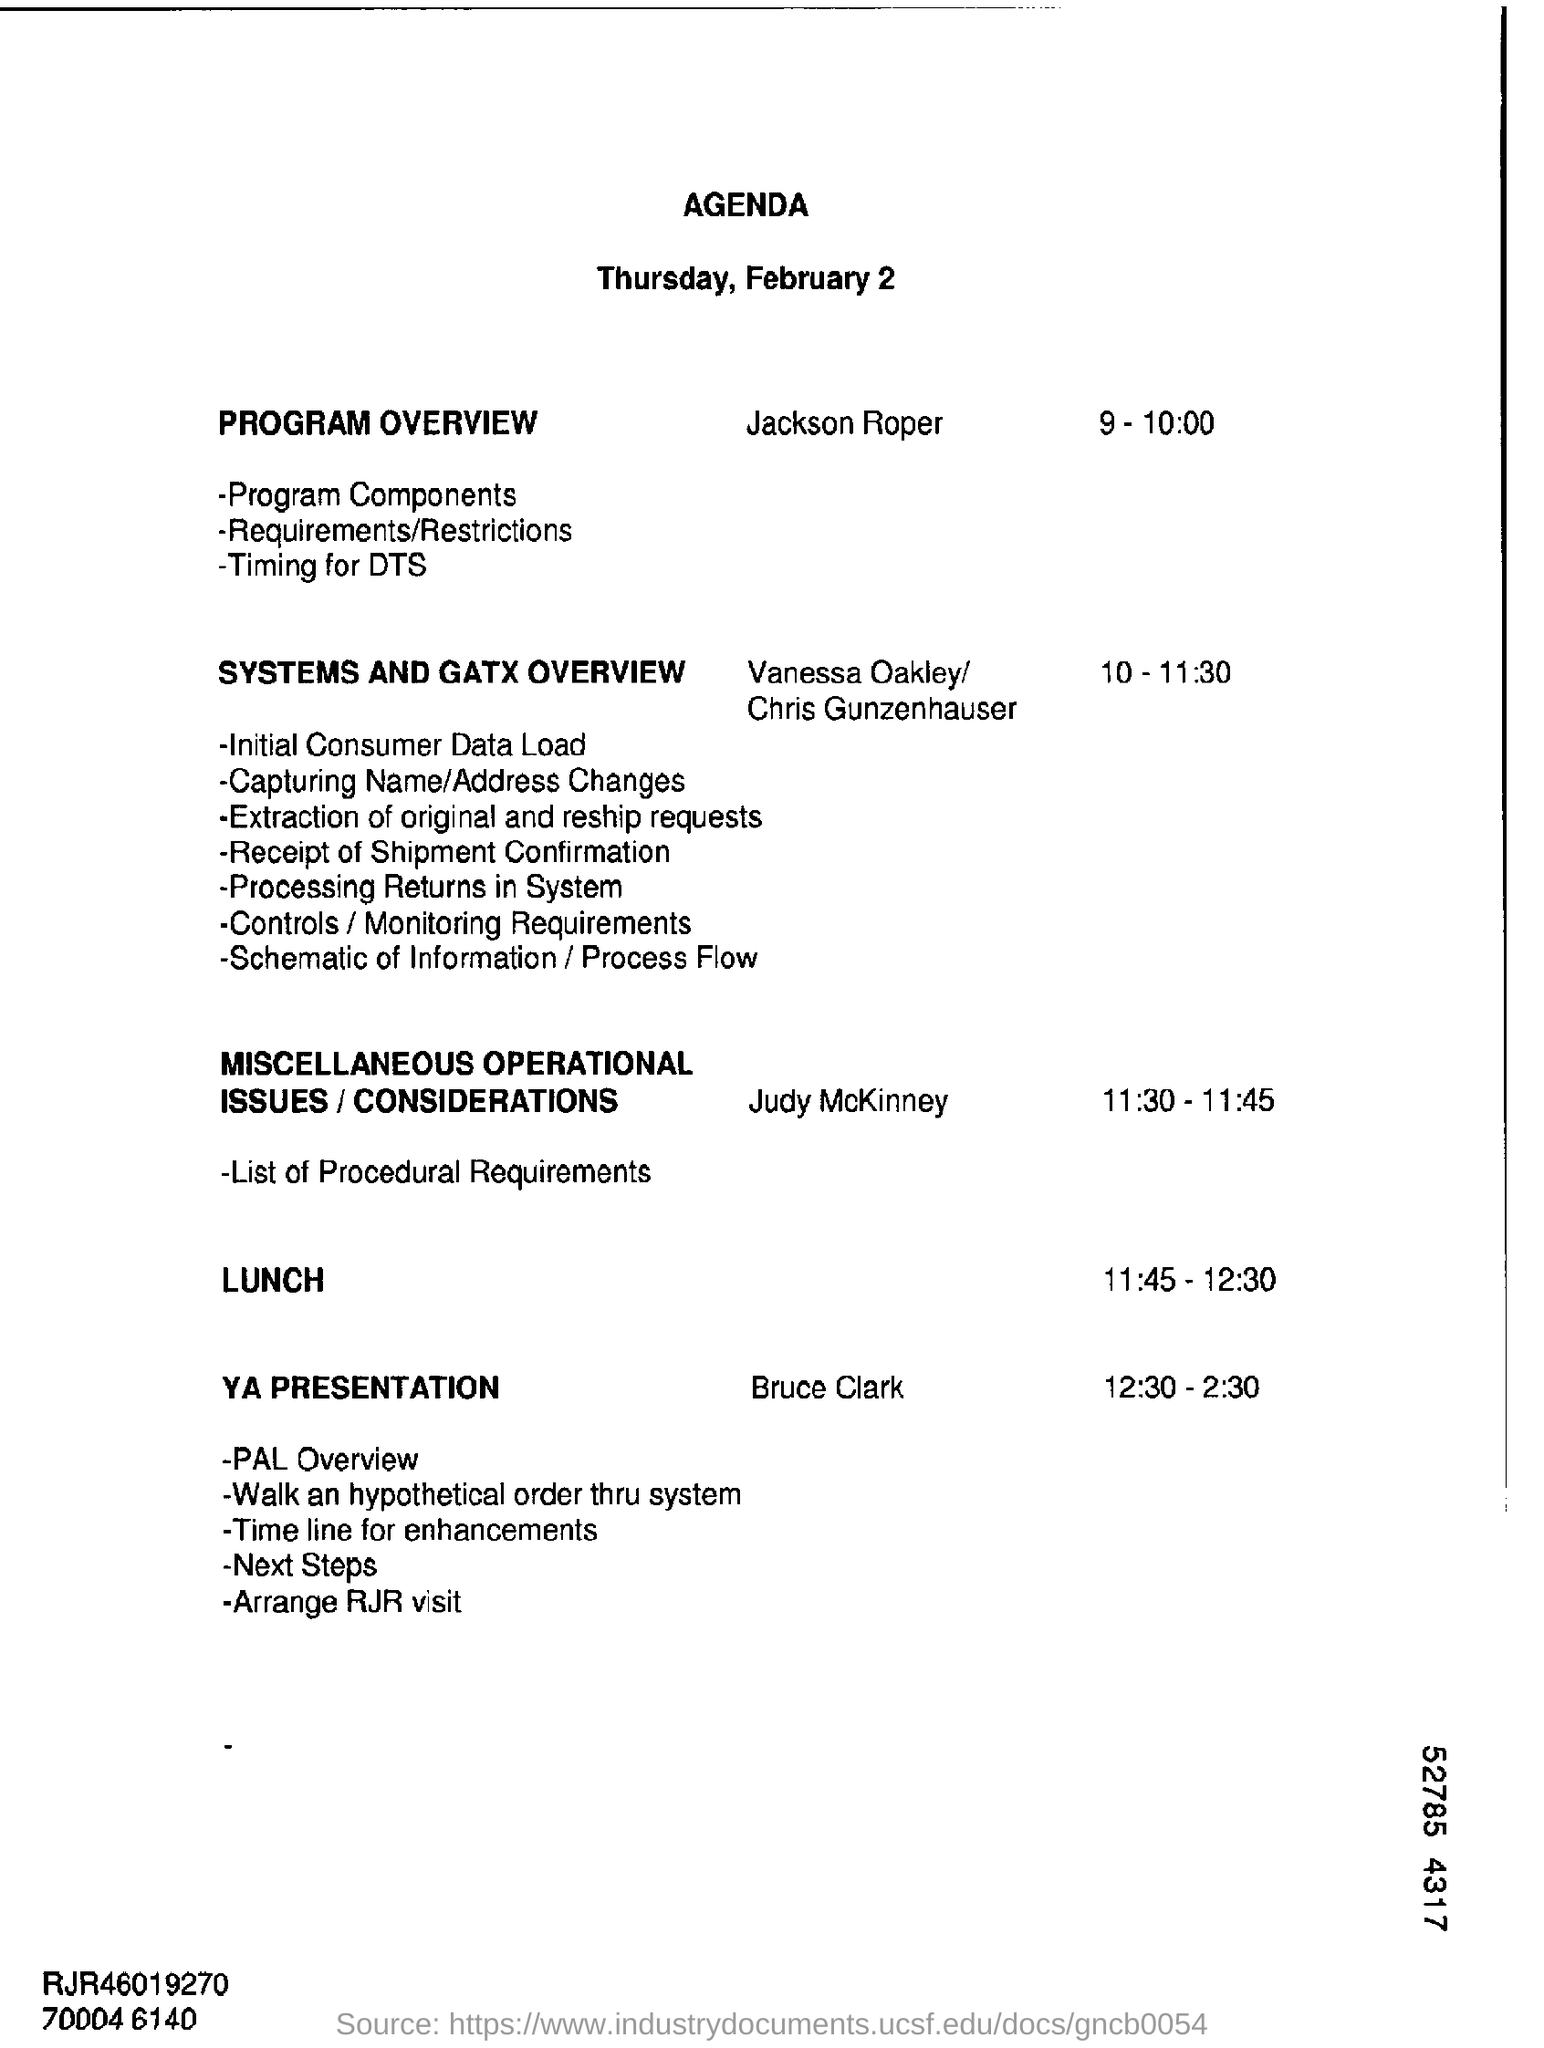Mention Agenda's day and date ?
Offer a terse response. Thursday, February 2. What is the final session of 'PROGRAM OVERVIEW' ?
Make the answer very short. TIMING FOR DTS. Who is in charge for PROGRAM OVERVIEW ?
Provide a short and direct response. JACKSON ROPER. What is the allotted time for PROGRAM OVERVIEW?
Provide a succinct answer. 9-10:00. Who conducted the activity before LUNCH in this AGENDA?
Your answer should be compact. Judy McKinney. What is the first event of 'YA PRESENTATION' activity?
Provide a succinct answer. PAL Overview. What is the allotted LUNCH TIME ?
Provide a short and direct response. 11:45 - 12:30. 